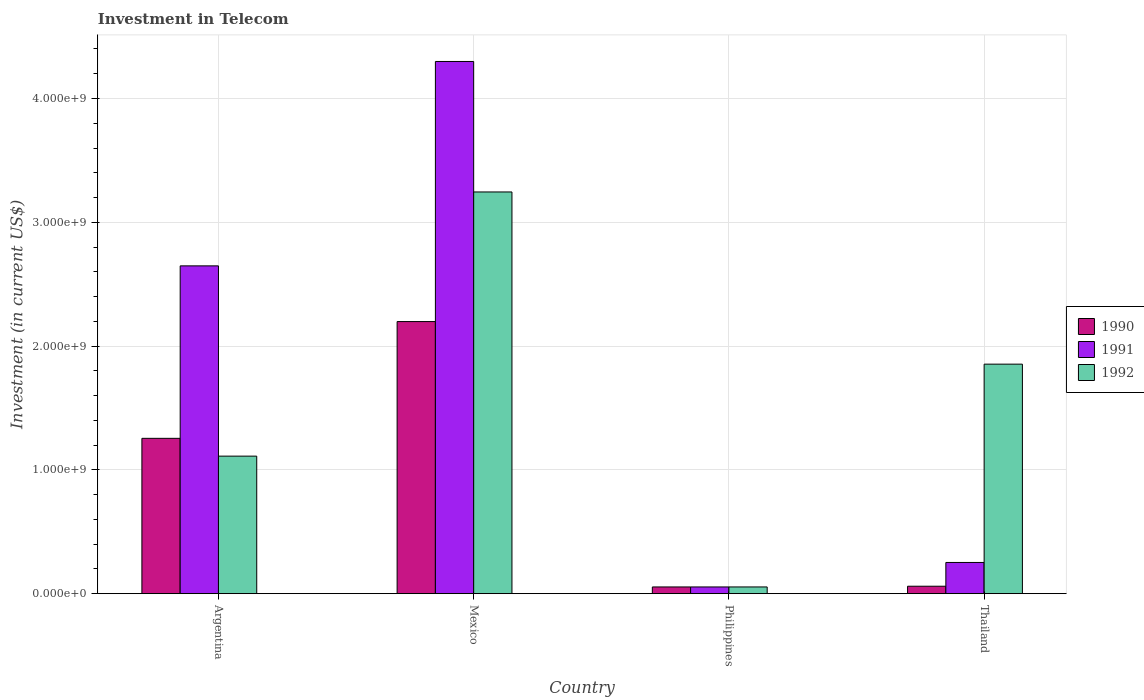Are the number of bars on each tick of the X-axis equal?
Ensure brevity in your answer.  Yes. What is the amount invested in telecom in 1992 in Thailand?
Your response must be concise. 1.85e+09. Across all countries, what is the maximum amount invested in telecom in 1992?
Provide a succinct answer. 3.24e+09. Across all countries, what is the minimum amount invested in telecom in 1991?
Your answer should be compact. 5.42e+07. In which country was the amount invested in telecom in 1992 maximum?
Offer a terse response. Mexico. What is the total amount invested in telecom in 1990 in the graph?
Your response must be concise. 3.57e+09. What is the difference between the amount invested in telecom in 1991 in Mexico and that in Thailand?
Provide a succinct answer. 4.05e+09. What is the difference between the amount invested in telecom in 1991 in Thailand and the amount invested in telecom in 1990 in Philippines?
Your answer should be compact. 1.98e+08. What is the average amount invested in telecom in 1991 per country?
Your answer should be compact. 1.81e+09. What is the difference between the amount invested in telecom of/in 1991 and amount invested in telecom of/in 1992 in Mexico?
Your response must be concise. 1.05e+09. In how many countries, is the amount invested in telecom in 1991 greater than 4200000000 US$?
Provide a succinct answer. 1. What is the ratio of the amount invested in telecom in 1991 in Argentina to that in Thailand?
Ensure brevity in your answer.  10.51. Is the amount invested in telecom in 1990 in Argentina less than that in Thailand?
Make the answer very short. No. Is the difference between the amount invested in telecom in 1991 in Argentina and Mexico greater than the difference between the amount invested in telecom in 1992 in Argentina and Mexico?
Your answer should be compact. Yes. What is the difference between the highest and the second highest amount invested in telecom in 1992?
Your answer should be compact. 1.39e+09. What is the difference between the highest and the lowest amount invested in telecom in 1991?
Provide a succinct answer. 4.24e+09. Are all the bars in the graph horizontal?
Keep it short and to the point. No. How many countries are there in the graph?
Offer a terse response. 4. Are the values on the major ticks of Y-axis written in scientific E-notation?
Offer a very short reply. Yes. Does the graph contain any zero values?
Provide a short and direct response. No. Where does the legend appear in the graph?
Make the answer very short. Center right. How many legend labels are there?
Give a very brief answer. 3. What is the title of the graph?
Give a very brief answer. Investment in Telecom. What is the label or title of the Y-axis?
Provide a short and direct response. Investment (in current US$). What is the Investment (in current US$) of 1990 in Argentina?
Make the answer very short. 1.25e+09. What is the Investment (in current US$) of 1991 in Argentina?
Your answer should be very brief. 2.65e+09. What is the Investment (in current US$) in 1992 in Argentina?
Make the answer very short. 1.11e+09. What is the Investment (in current US$) in 1990 in Mexico?
Offer a very short reply. 2.20e+09. What is the Investment (in current US$) in 1991 in Mexico?
Your response must be concise. 4.30e+09. What is the Investment (in current US$) in 1992 in Mexico?
Provide a short and direct response. 3.24e+09. What is the Investment (in current US$) in 1990 in Philippines?
Give a very brief answer. 5.42e+07. What is the Investment (in current US$) of 1991 in Philippines?
Offer a terse response. 5.42e+07. What is the Investment (in current US$) of 1992 in Philippines?
Your answer should be very brief. 5.42e+07. What is the Investment (in current US$) in 1990 in Thailand?
Your answer should be compact. 6.00e+07. What is the Investment (in current US$) of 1991 in Thailand?
Give a very brief answer. 2.52e+08. What is the Investment (in current US$) of 1992 in Thailand?
Provide a succinct answer. 1.85e+09. Across all countries, what is the maximum Investment (in current US$) of 1990?
Provide a succinct answer. 2.20e+09. Across all countries, what is the maximum Investment (in current US$) of 1991?
Offer a very short reply. 4.30e+09. Across all countries, what is the maximum Investment (in current US$) in 1992?
Offer a very short reply. 3.24e+09. Across all countries, what is the minimum Investment (in current US$) in 1990?
Your answer should be compact. 5.42e+07. Across all countries, what is the minimum Investment (in current US$) of 1991?
Make the answer very short. 5.42e+07. Across all countries, what is the minimum Investment (in current US$) in 1992?
Your response must be concise. 5.42e+07. What is the total Investment (in current US$) in 1990 in the graph?
Give a very brief answer. 3.57e+09. What is the total Investment (in current US$) in 1991 in the graph?
Keep it short and to the point. 7.25e+09. What is the total Investment (in current US$) in 1992 in the graph?
Make the answer very short. 6.26e+09. What is the difference between the Investment (in current US$) of 1990 in Argentina and that in Mexico?
Offer a terse response. -9.43e+08. What is the difference between the Investment (in current US$) in 1991 in Argentina and that in Mexico?
Your answer should be very brief. -1.65e+09. What is the difference between the Investment (in current US$) of 1992 in Argentina and that in Mexico?
Offer a very short reply. -2.13e+09. What is the difference between the Investment (in current US$) of 1990 in Argentina and that in Philippines?
Your response must be concise. 1.20e+09. What is the difference between the Investment (in current US$) in 1991 in Argentina and that in Philippines?
Keep it short and to the point. 2.59e+09. What is the difference between the Investment (in current US$) of 1992 in Argentina and that in Philippines?
Provide a short and direct response. 1.06e+09. What is the difference between the Investment (in current US$) of 1990 in Argentina and that in Thailand?
Give a very brief answer. 1.19e+09. What is the difference between the Investment (in current US$) in 1991 in Argentina and that in Thailand?
Provide a succinct answer. 2.40e+09. What is the difference between the Investment (in current US$) of 1992 in Argentina and that in Thailand?
Offer a very short reply. -7.43e+08. What is the difference between the Investment (in current US$) of 1990 in Mexico and that in Philippines?
Provide a short and direct response. 2.14e+09. What is the difference between the Investment (in current US$) of 1991 in Mexico and that in Philippines?
Ensure brevity in your answer.  4.24e+09. What is the difference between the Investment (in current US$) of 1992 in Mexico and that in Philippines?
Offer a terse response. 3.19e+09. What is the difference between the Investment (in current US$) in 1990 in Mexico and that in Thailand?
Offer a very short reply. 2.14e+09. What is the difference between the Investment (in current US$) in 1991 in Mexico and that in Thailand?
Your answer should be compact. 4.05e+09. What is the difference between the Investment (in current US$) in 1992 in Mexico and that in Thailand?
Offer a terse response. 1.39e+09. What is the difference between the Investment (in current US$) in 1990 in Philippines and that in Thailand?
Your answer should be very brief. -5.80e+06. What is the difference between the Investment (in current US$) in 1991 in Philippines and that in Thailand?
Make the answer very short. -1.98e+08. What is the difference between the Investment (in current US$) of 1992 in Philippines and that in Thailand?
Your response must be concise. -1.80e+09. What is the difference between the Investment (in current US$) of 1990 in Argentina and the Investment (in current US$) of 1991 in Mexico?
Provide a succinct answer. -3.04e+09. What is the difference between the Investment (in current US$) of 1990 in Argentina and the Investment (in current US$) of 1992 in Mexico?
Provide a short and direct response. -1.99e+09. What is the difference between the Investment (in current US$) of 1991 in Argentina and the Investment (in current US$) of 1992 in Mexico?
Ensure brevity in your answer.  -5.97e+08. What is the difference between the Investment (in current US$) of 1990 in Argentina and the Investment (in current US$) of 1991 in Philippines?
Your response must be concise. 1.20e+09. What is the difference between the Investment (in current US$) of 1990 in Argentina and the Investment (in current US$) of 1992 in Philippines?
Offer a very short reply. 1.20e+09. What is the difference between the Investment (in current US$) of 1991 in Argentina and the Investment (in current US$) of 1992 in Philippines?
Your answer should be compact. 2.59e+09. What is the difference between the Investment (in current US$) of 1990 in Argentina and the Investment (in current US$) of 1991 in Thailand?
Your answer should be compact. 1.00e+09. What is the difference between the Investment (in current US$) in 1990 in Argentina and the Investment (in current US$) in 1992 in Thailand?
Keep it short and to the point. -5.99e+08. What is the difference between the Investment (in current US$) in 1991 in Argentina and the Investment (in current US$) in 1992 in Thailand?
Provide a short and direct response. 7.94e+08. What is the difference between the Investment (in current US$) of 1990 in Mexico and the Investment (in current US$) of 1991 in Philippines?
Your answer should be very brief. 2.14e+09. What is the difference between the Investment (in current US$) in 1990 in Mexico and the Investment (in current US$) in 1992 in Philippines?
Provide a short and direct response. 2.14e+09. What is the difference between the Investment (in current US$) in 1991 in Mexico and the Investment (in current US$) in 1992 in Philippines?
Your answer should be compact. 4.24e+09. What is the difference between the Investment (in current US$) of 1990 in Mexico and the Investment (in current US$) of 1991 in Thailand?
Provide a succinct answer. 1.95e+09. What is the difference between the Investment (in current US$) in 1990 in Mexico and the Investment (in current US$) in 1992 in Thailand?
Make the answer very short. 3.44e+08. What is the difference between the Investment (in current US$) in 1991 in Mexico and the Investment (in current US$) in 1992 in Thailand?
Your answer should be compact. 2.44e+09. What is the difference between the Investment (in current US$) in 1990 in Philippines and the Investment (in current US$) in 1991 in Thailand?
Offer a very short reply. -1.98e+08. What is the difference between the Investment (in current US$) of 1990 in Philippines and the Investment (in current US$) of 1992 in Thailand?
Ensure brevity in your answer.  -1.80e+09. What is the difference between the Investment (in current US$) in 1991 in Philippines and the Investment (in current US$) in 1992 in Thailand?
Your answer should be very brief. -1.80e+09. What is the average Investment (in current US$) in 1990 per country?
Offer a very short reply. 8.92e+08. What is the average Investment (in current US$) in 1991 per country?
Ensure brevity in your answer.  1.81e+09. What is the average Investment (in current US$) of 1992 per country?
Offer a very short reply. 1.57e+09. What is the difference between the Investment (in current US$) of 1990 and Investment (in current US$) of 1991 in Argentina?
Keep it short and to the point. -1.39e+09. What is the difference between the Investment (in current US$) in 1990 and Investment (in current US$) in 1992 in Argentina?
Your answer should be compact. 1.44e+08. What is the difference between the Investment (in current US$) of 1991 and Investment (in current US$) of 1992 in Argentina?
Give a very brief answer. 1.54e+09. What is the difference between the Investment (in current US$) in 1990 and Investment (in current US$) in 1991 in Mexico?
Keep it short and to the point. -2.10e+09. What is the difference between the Investment (in current US$) in 1990 and Investment (in current US$) in 1992 in Mexico?
Keep it short and to the point. -1.05e+09. What is the difference between the Investment (in current US$) in 1991 and Investment (in current US$) in 1992 in Mexico?
Offer a very short reply. 1.05e+09. What is the difference between the Investment (in current US$) in 1990 and Investment (in current US$) in 1991 in Philippines?
Ensure brevity in your answer.  0. What is the difference between the Investment (in current US$) of 1990 and Investment (in current US$) of 1992 in Philippines?
Keep it short and to the point. 0. What is the difference between the Investment (in current US$) of 1990 and Investment (in current US$) of 1991 in Thailand?
Provide a short and direct response. -1.92e+08. What is the difference between the Investment (in current US$) of 1990 and Investment (in current US$) of 1992 in Thailand?
Provide a succinct answer. -1.79e+09. What is the difference between the Investment (in current US$) in 1991 and Investment (in current US$) in 1992 in Thailand?
Offer a terse response. -1.60e+09. What is the ratio of the Investment (in current US$) in 1990 in Argentina to that in Mexico?
Provide a short and direct response. 0.57. What is the ratio of the Investment (in current US$) in 1991 in Argentina to that in Mexico?
Provide a succinct answer. 0.62. What is the ratio of the Investment (in current US$) in 1992 in Argentina to that in Mexico?
Your response must be concise. 0.34. What is the ratio of the Investment (in current US$) of 1990 in Argentina to that in Philippines?
Keep it short and to the point. 23.15. What is the ratio of the Investment (in current US$) of 1991 in Argentina to that in Philippines?
Provide a succinct answer. 48.86. What is the ratio of the Investment (in current US$) in 1992 in Argentina to that in Philippines?
Your answer should be very brief. 20.5. What is the ratio of the Investment (in current US$) of 1990 in Argentina to that in Thailand?
Keep it short and to the point. 20.91. What is the ratio of the Investment (in current US$) in 1991 in Argentina to that in Thailand?
Your answer should be very brief. 10.51. What is the ratio of the Investment (in current US$) in 1992 in Argentina to that in Thailand?
Make the answer very short. 0.6. What is the ratio of the Investment (in current US$) in 1990 in Mexico to that in Philippines?
Provide a short and direct response. 40.55. What is the ratio of the Investment (in current US$) in 1991 in Mexico to that in Philippines?
Ensure brevity in your answer.  79.32. What is the ratio of the Investment (in current US$) of 1992 in Mexico to that in Philippines?
Provide a short and direct response. 59.87. What is the ratio of the Investment (in current US$) of 1990 in Mexico to that in Thailand?
Provide a short and direct response. 36.63. What is the ratio of the Investment (in current US$) of 1991 in Mexico to that in Thailand?
Give a very brief answer. 17.06. What is the ratio of the Investment (in current US$) in 1992 in Mexico to that in Thailand?
Offer a very short reply. 1.75. What is the ratio of the Investment (in current US$) of 1990 in Philippines to that in Thailand?
Provide a succinct answer. 0.9. What is the ratio of the Investment (in current US$) of 1991 in Philippines to that in Thailand?
Offer a very short reply. 0.22. What is the ratio of the Investment (in current US$) of 1992 in Philippines to that in Thailand?
Offer a very short reply. 0.03. What is the difference between the highest and the second highest Investment (in current US$) of 1990?
Make the answer very short. 9.43e+08. What is the difference between the highest and the second highest Investment (in current US$) in 1991?
Your answer should be compact. 1.65e+09. What is the difference between the highest and the second highest Investment (in current US$) of 1992?
Ensure brevity in your answer.  1.39e+09. What is the difference between the highest and the lowest Investment (in current US$) of 1990?
Give a very brief answer. 2.14e+09. What is the difference between the highest and the lowest Investment (in current US$) of 1991?
Offer a very short reply. 4.24e+09. What is the difference between the highest and the lowest Investment (in current US$) of 1992?
Offer a terse response. 3.19e+09. 